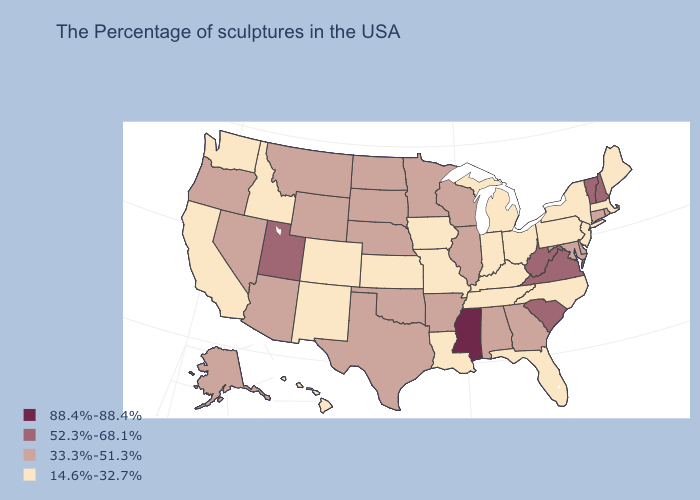Is the legend a continuous bar?
Be succinct. No. What is the value of Arizona?
Short answer required. 33.3%-51.3%. Among the states that border Wisconsin , does Minnesota have the lowest value?
Write a very short answer. No. Which states have the lowest value in the USA?
Answer briefly. Maine, Massachusetts, New York, New Jersey, Pennsylvania, North Carolina, Ohio, Florida, Michigan, Kentucky, Indiana, Tennessee, Louisiana, Missouri, Iowa, Kansas, Colorado, New Mexico, Idaho, California, Washington, Hawaii. Among the states that border New Hampshire , which have the highest value?
Quick response, please. Vermont. How many symbols are there in the legend?
Give a very brief answer. 4. What is the highest value in the Northeast ?
Be succinct. 52.3%-68.1%. Does the first symbol in the legend represent the smallest category?
Short answer required. No. Does Colorado have the lowest value in the West?
Keep it brief. Yes. What is the value of Louisiana?
Keep it brief. 14.6%-32.7%. What is the lowest value in the USA?
Concise answer only. 14.6%-32.7%. Name the states that have a value in the range 33.3%-51.3%?
Keep it brief. Rhode Island, Connecticut, Delaware, Maryland, Georgia, Alabama, Wisconsin, Illinois, Arkansas, Minnesota, Nebraska, Oklahoma, Texas, South Dakota, North Dakota, Wyoming, Montana, Arizona, Nevada, Oregon, Alaska. What is the lowest value in states that border California?
Quick response, please. 33.3%-51.3%. What is the value of Delaware?
Answer briefly. 33.3%-51.3%. What is the highest value in the West ?
Keep it brief. 52.3%-68.1%. 